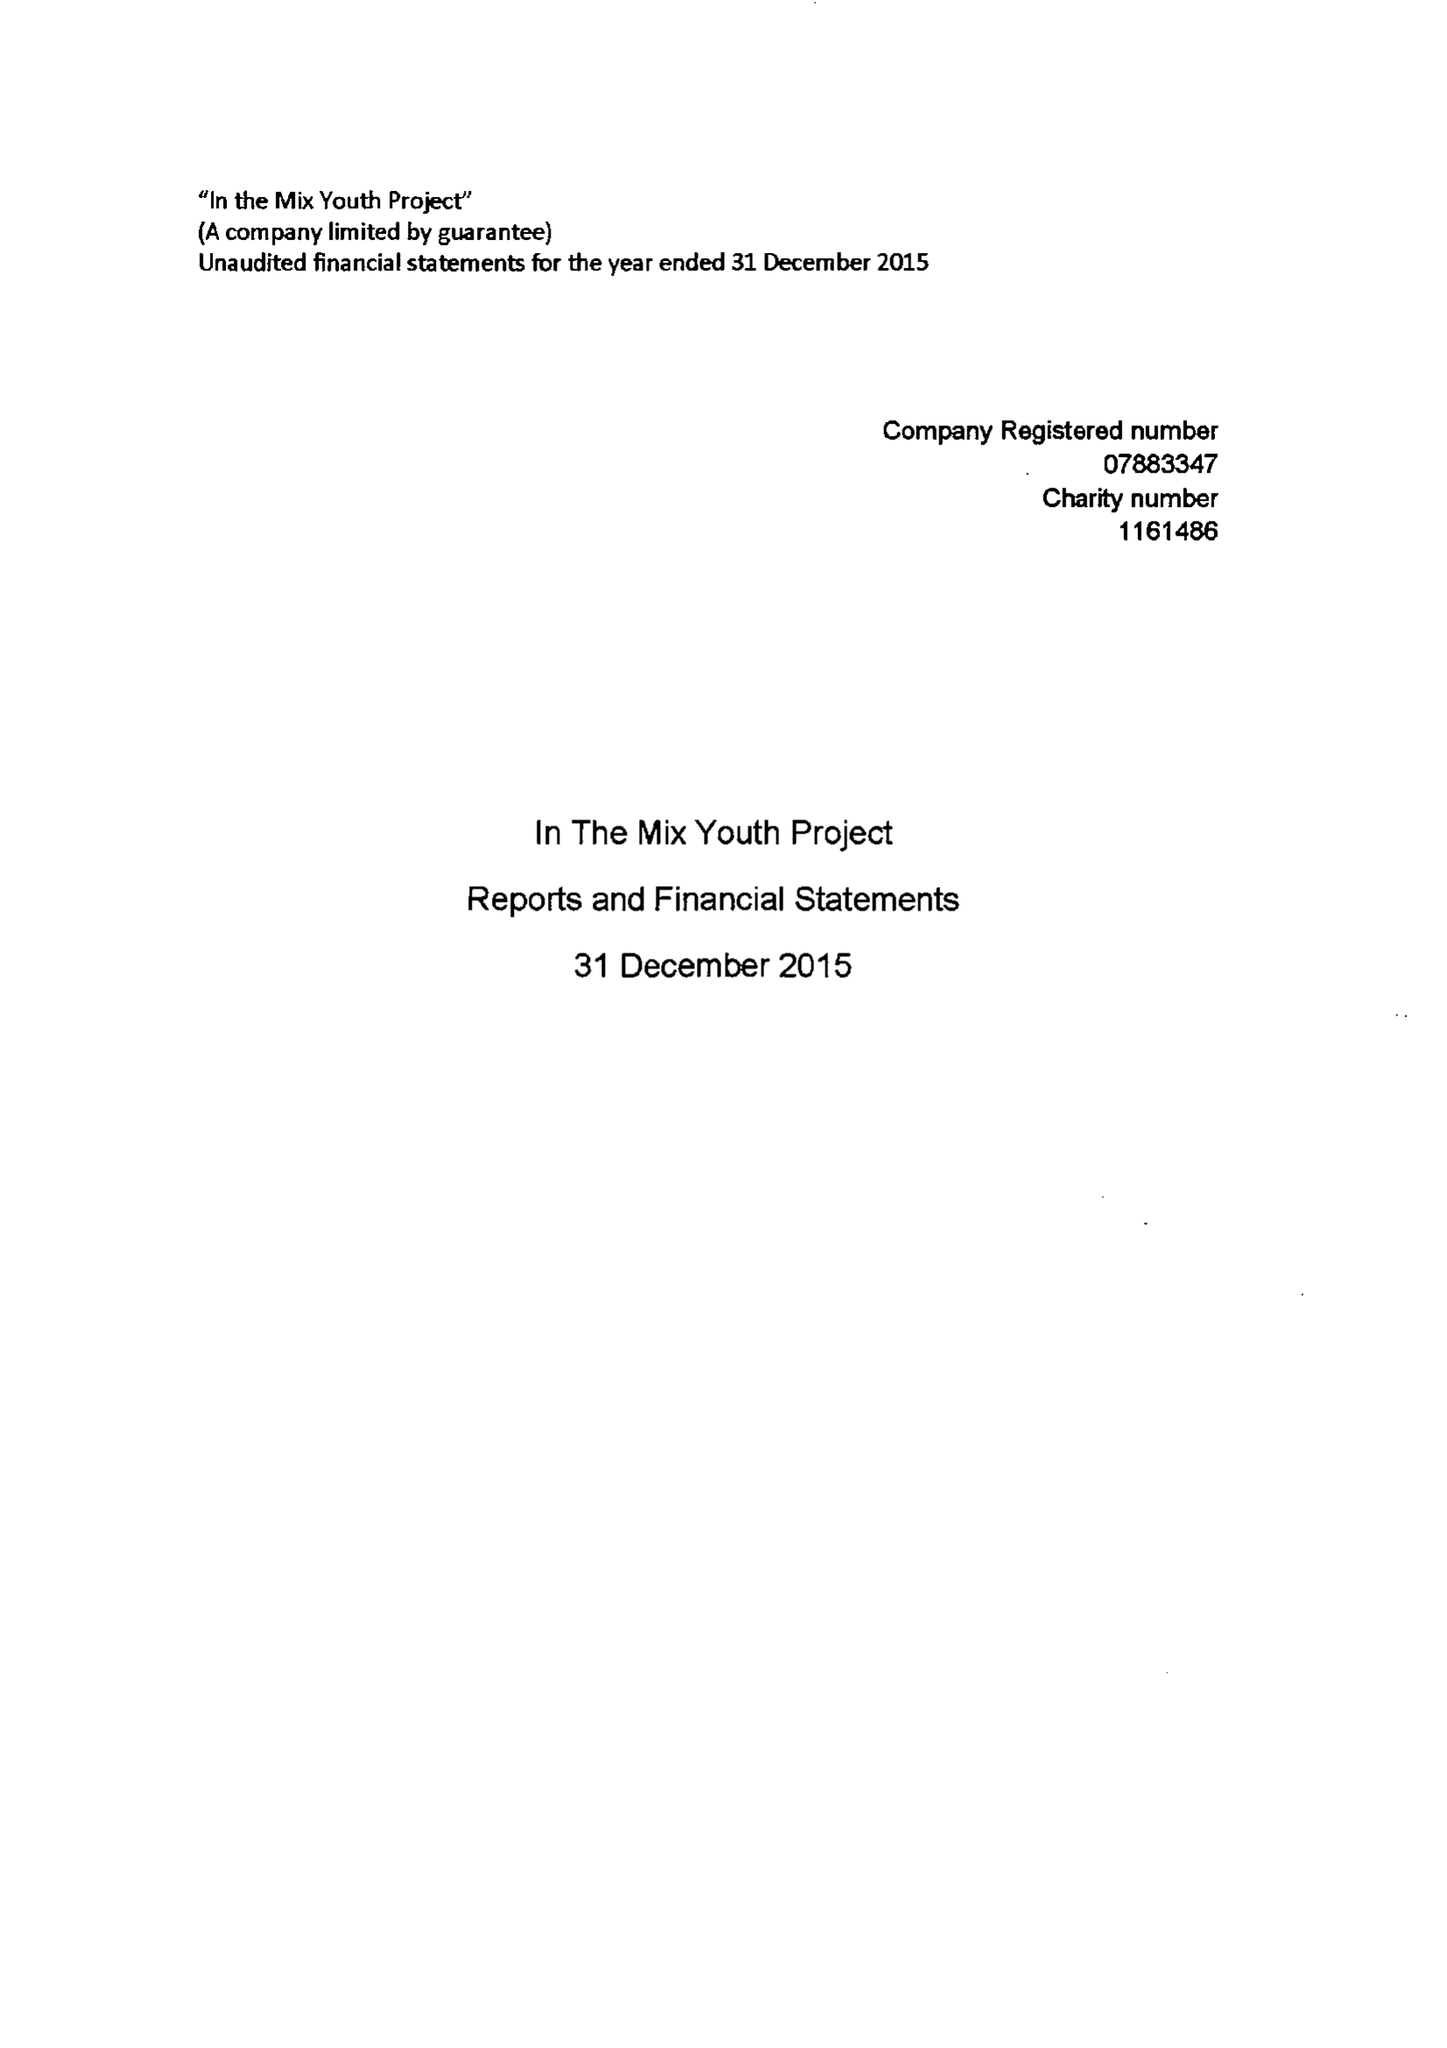What is the value for the address__postcode?
Answer the question using a single word or phrase. TA4 2NE 